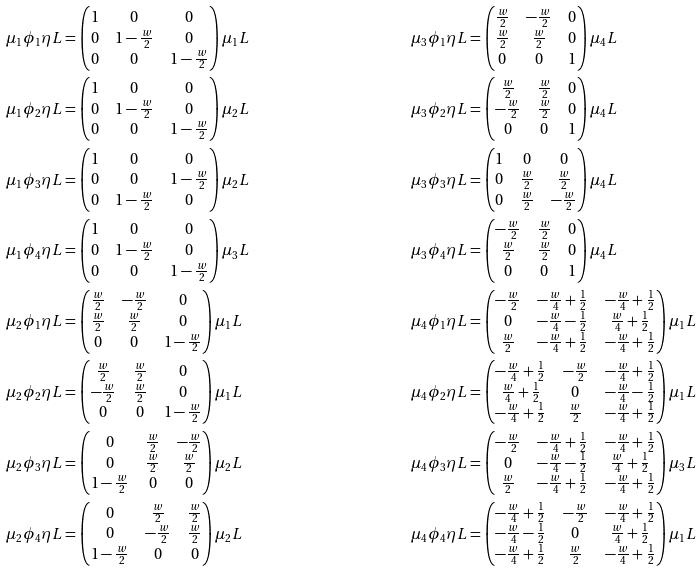<formula> <loc_0><loc_0><loc_500><loc_500>\mu _ { 1 } \phi _ { 1 } \eta L & = \begin{pmatrix} 1 & 0 & 0 \\ 0 & 1 - \frac { w } { 2 } & 0 \\ 0 & 0 & 1 - \frac { w } { 2 } \end{pmatrix} \mu _ { 1 } L & \mu _ { 3 } \phi _ { 1 } \eta L & = \begin{pmatrix} \frac { w } { 2 } & - \frac { w } { 2 } & 0 \\ \frac { w } { 2 } & \frac { w } { 2 } & 0 \\ 0 & 0 & 1 \end{pmatrix} \mu _ { 4 } L \\ \mu _ { 1 } \phi _ { 2 } \eta L & = \begin{pmatrix} 1 & 0 & 0 \\ 0 & 1 - \frac { w } { 2 } & 0 \\ 0 & 0 & 1 - \frac { w } { 2 } \end{pmatrix} \mu _ { 2 } L & \mu _ { 3 } \phi _ { 2 } \eta L & = \begin{pmatrix} \frac { w } { 2 } & \frac { w } { 2 } & 0 \\ - \frac { w } { 2 } & \frac { w } { 2 } & 0 \\ 0 & 0 & 1 \end{pmatrix} \mu _ { 4 } L \\ \mu _ { 1 } \phi _ { 3 } \eta L & = \begin{pmatrix} 1 & 0 & 0 \\ 0 & 0 & 1 - \frac { w } { 2 } \\ 0 & 1 - \frac { w } { 2 } & 0 \end{pmatrix} \mu _ { 2 } L & \mu _ { 3 } \phi _ { 3 } \eta L & = \begin{pmatrix} 1 & 0 & 0 \\ 0 & \frac { w } { 2 } & \frac { w } { 2 } \\ 0 & \frac { w } { 2 } & - \frac { w } { 2 } \end{pmatrix} \mu _ { 4 } L \\ \mu _ { 1 } \phi _ { 4 } \eta L & = \begin{pmatrix} 1 & 0 & 0 \\ 0 & 1 - \frac { w } { 2 } & 0 \\ 0 & 0 & 1 - \frac { w } { 2 } \end{pmatrix} \mu _ { 3 } L & \mu _ { 3 } \phi _ { 4 } \eta L & = \begin{pmatrix} - \frac { w } { 2 } & \frac { w } { 2 } & 0 \\ \frac { w } { 2 } & \frac { w } { 2 } & 0 \\ 0 & 0 & 1 \end{pmatrix} \mu _ { 4 } L \\ \mu _ { 2 } \phi _ { 1 } \eta L & = \begin{pmatrix} \frac { w } { 2 } & - \frac { w } { 2 } & 0 \\ \frac { w } { 2 } & \frac { w } { 2 } & 0 \\ 0 & 0 & 1 - \frac { w } { 2 } \end{pmatrix} \mu _ { 1 } L & \mu _ { 4 } \phi _ { 1 } \eta L & = \begin{pmatrix} - \frac { w } { 2 } & - \frac { w } { 4 } + \frac { 1 } { 2 } & - \frac { w } { 4 } + \frac { 1 } { 2 } \\ 0 & - \frac { w } { 4 } - \frac { 1 } { 2 } & \frac { w } { 4 } + \frac { 1 } { 2 } \\ \frac { w } { 2 } & - \frac { w } { 4 } + \frac { 1 } { 2 } & - \frac { w } { 4 } + \frac { 1 } { 2 } \end{pmatrix} \mu _ { 1 } L \\ \mu _ { 2 } \phi _ { 2 } \eta L & = \begin{pmatrix} \frac { w } { 2 } & \frac { w } { 2 } & 0 \\ - \frac { w } { 2 } & \frac { w } { 2 } & 0 \\ 0 & 0 & 1 - \frac { w } { 2 } \end{pmatrix} \mu _ { 1 } L & \mu _ { 4 } \phi _ { 2 } \eta L & = \begin{pmatrix} - \frac { w } { 4 } + \frac { 1 } { 2 } & - \frac { w } { 2 } & - \frac { w } { 4 } + \frac { 1 } { 2 } \\ \frac { w } { 4 } + \frac { 1 } { 2 } & 0 & - \frac { w } { 4 } - \frac { 1 } { 2 } \\ - \frac { w } { 4 } + \frac { 1 } { 2 } & \frac { w } { 2 } & - \frac { w } { 4 } + \frac { 1 } { 2 } \end{pmatrix} \mu _ { 1 } L \\ \mu _ { 2 } \phi _ { 3 } \eta L & = \begin{pmatrix} 0 & \frac { w } { 2 } & - \frac { w } { 2 } \\ 0 & \frac { w } { 2 } & \frac { w } { 2 } \\ 1 - \frac { w } { 2 } & 0 & 0 \end{pmatrix} \mu _ { 2 } L & \mu _ { 4 } \phi _ { 3 } \eta L & = \begin{pmatrix} - \frac { w } { 2 } & - \frac { w } { 4 } + \frac { 1 } { 2 } & - \frac { w } { 4 } + \frac { 1 } { 2 } \\ 0 & - \frac { w } { 4 } - \frac { 1 } { 2 } & \frac { w } { 4 } + \frac { 1 } { 2 } \\ \frac { w } { 2 } & - \frac { w } { 4 } + \frac { 1 } { 2 } & - \frac { w } { 4 } + \frac { 1 } { 2 } \end{pmatrix} \mu _ { 3 } L \\ \mu _ { 2 } \phi _ { 4 } \eta L & = \begin{pmatrix} 0 & \frac { w } { 2 } & \frac { w } { 2 } \\ 0 & - \frac { w } { 2 } & \frac { w } { 2 } \\ 1 - \frac { w } { 2 } & 0 & 0 \end{pmatrix} \mu _ { 2 } L & \mu _ { 4 } \phi _ { 4 } \eta L & = \begin{pmatrix} - \frac { w } { 4 } + \frac { 1 } { 2 } & - \frac { w } { 2 } & - \frac { w } { 4 } + \frac { 1 } { 2 } \\ - \frac { w } { 4 } - \frac { 1 } { 2 } & 0 & \frac { w } { 4 } + \frac { 1 } { 2 } \\ - \frac { w } { 4 } + \frac { 1 } { 2 } & \frac { w } { 2 } & - \frac { w } { 4 } + \frac { 1 } { 2 } \end{pmatrix} \mu _ { 1 } L</formula> 